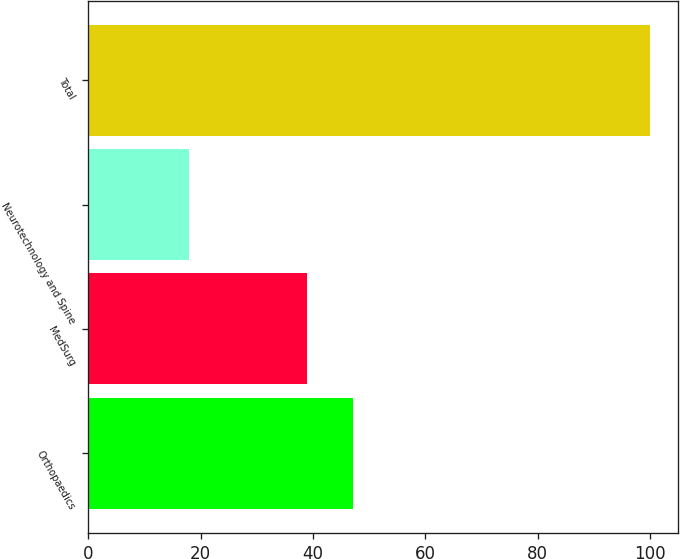Convert chart to OTSL. <chart><loc_0><loc_0><loc_500><loc_500><bar_chart><fcel>Orthopaedics<fcel>MedSurg<fcel>Neurotechnology and Spine<fcel>Total<nl><fcel>47.2<fcel>39<fcel>18<fcel>100<nl></chart> 